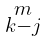<formula> <loc_0><loc_0><loc_500><loc_500>\begin{smallmatrix} m \\ k - j \end{smallmatrix}</formula> 